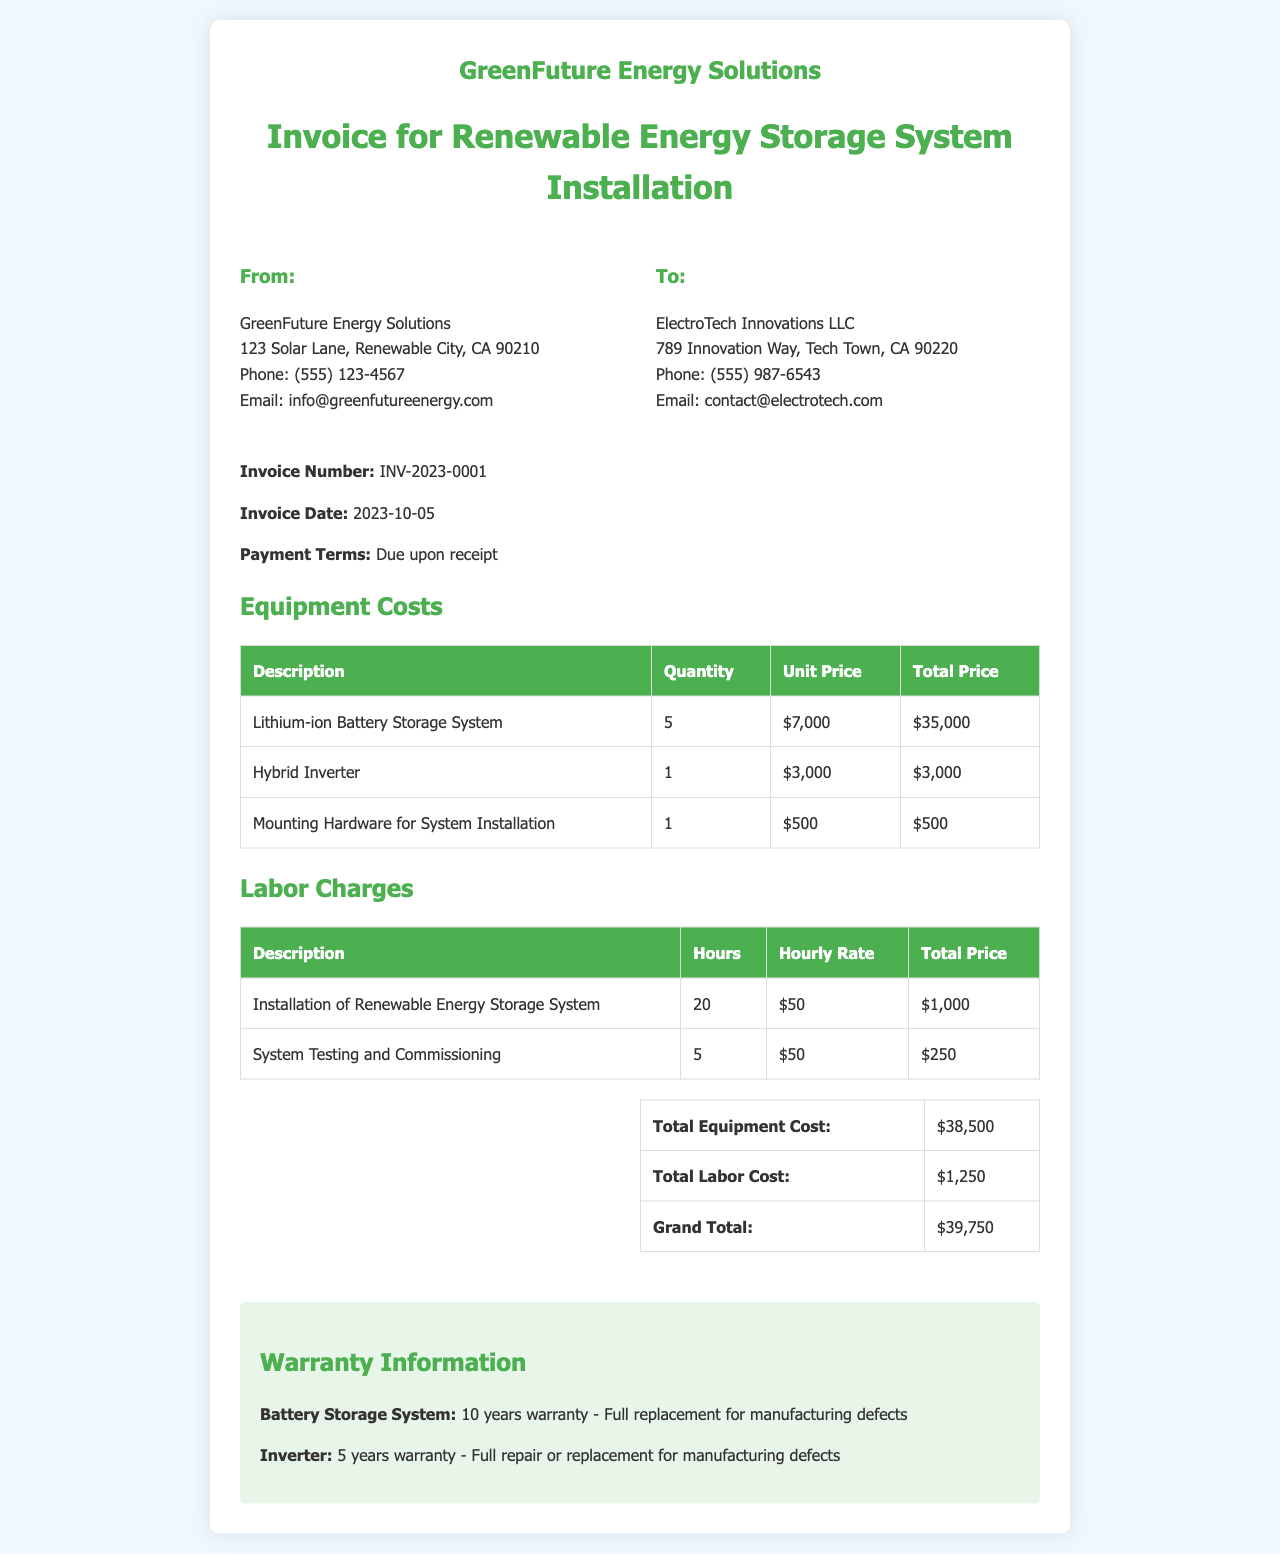What is the invoice number? The invoice number is specified in the document as a unique identifier for tracking purposes.
Answer: INV-2023-0001 What is the total equipment cost? The total equipment cost is explicitly listed in the summary section of the document.
Answer: $38,500 Who is the customer listed in the invoice? The customer is identified in the "To:" section, which provides the company's name and details.
Answer: ElectroTech Innovations LLC What is the hourly rate for labor charges? The document outlines the hourly rate for labor charges in the labor section.
Answer: $50 How long is the warranty for the battery storage system? The warranty information section details the coverage duration for the battery storage system.
Answer: 10 years What is the grand total amount due? The grand total is calculated as the sum of total equipment costs and total labor costs, presented in the summary.
Answer: $39,750 How many lithium-ion battery storage systems were included? The quantity of lithium-ion battery storage systems can be found in the equipment costs table under the specific item.
Answer: 5 What is the installation labor charge total? The total for installation labor can be found in the labor charges table where it's summarized at the end.
Answer: $1,000 What email address is provided for the company? The email address is provided in the company details section for contact purposes.
Answer: info@greenfutureenergy.com 